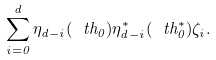Convert formula to latex. <formula><loc_0><loc_0><loc_500><loc_500>\sum _ { i = 0 } ^ { d } \eta _ { d - i } ( \ t h _ { 0 } ) \eta ^ { * } _ { d - i } ( \ t h ^ { * } _ { 0 } ) \zeta _ { i } .</formula> 